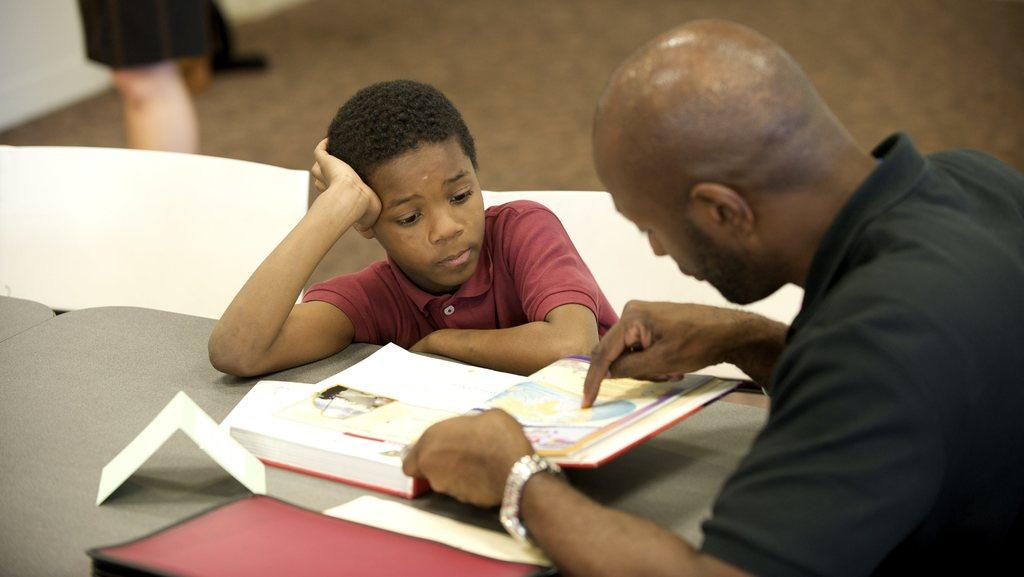What are the people in the image doing? There are persons sitting at the table in the image. What objects can be seen on the table? There are books on the table. What can be seen in the background of the image? There are human legs and a floor visible in the background. How many pigs are present at the party in the image? There is no party or pigs present in the image; it features persons sitting at a table with books. What type of feather can be seen on the person's hat in the image? There is no hat or feather visible in the image. 